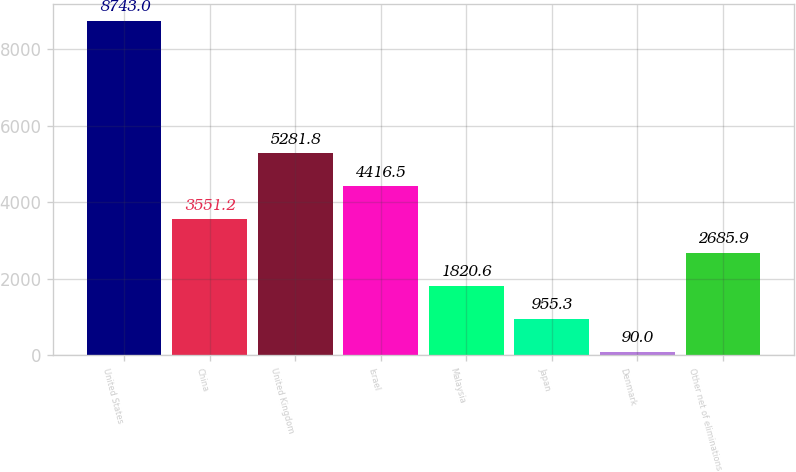Convert chart. <chart><loc_0><loc_0><loc_500><loc_500><bar_chart><fcel>United States<fcel>China<fcel>United Kingdom<fcel>Israel<fcel>Malaysia<fcel>Japan<fcel>Denmark<fcel>Other net of eliminations<nl><fcel>8743<fcel>3551.2<fcel>5281.8<fcel>4416.5<fcel>1820.6<fcel>955.3<fcel>90<fcel>2685.9<nl></chart> 